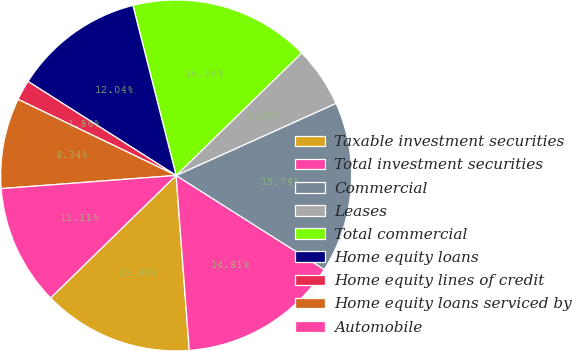Convert chart. <chart><loc_0><loc_0><loc_500><loc_500><pie_chart><fcel>Taxable investment securities<fcel>Total investment securities<fcel>Commercial<fcel>Leases<fcel>Total commercial<fcel>Home equity loans<fcel>Home equity lines of credit<fcel>Home equity loans serviced by<fcel>Automobile<nl><fcel>13.89%<fcel>14.81%<fcel>15.74%<fcel>5.56%<fcel>16.66%<fcel>12.04%<fcel>1.86%<fcel>8.34%<fcel>11.11%<nl></chart> 